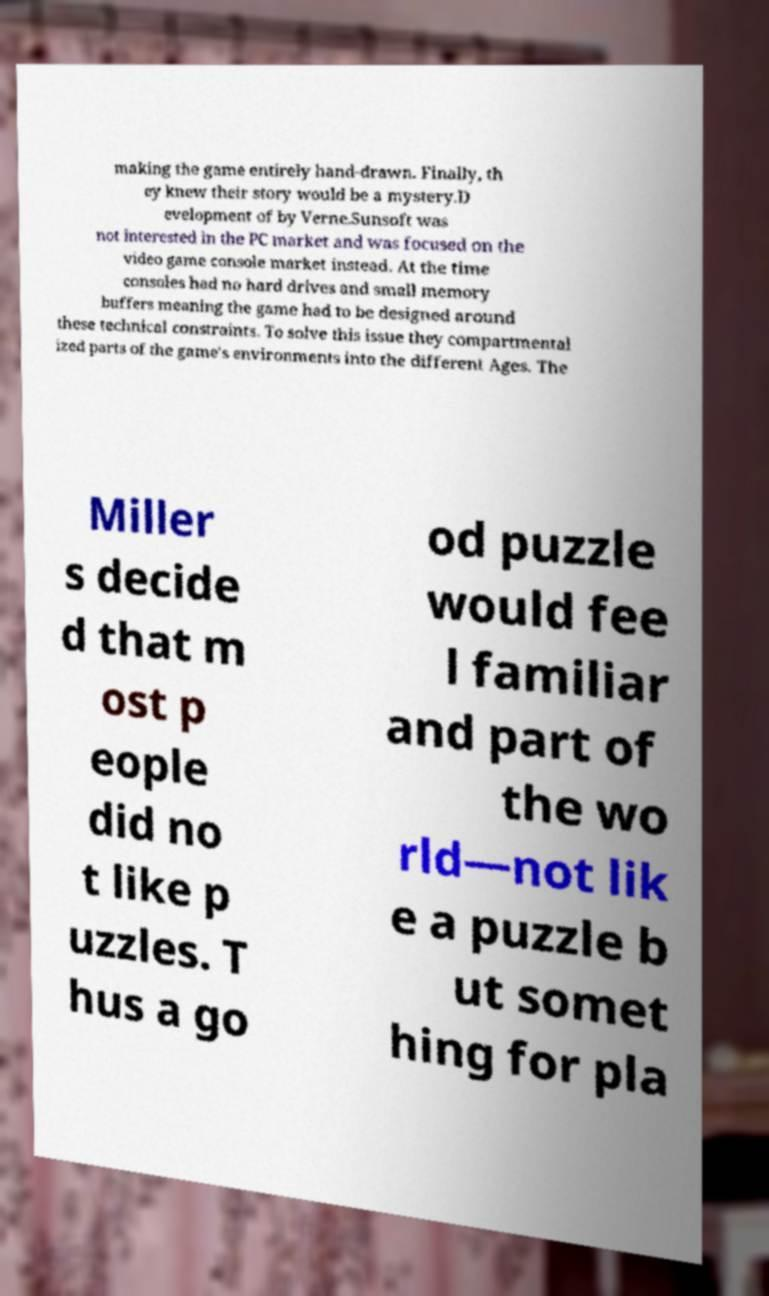Please identify and transcribe the text found in this image. making the game entirely hand-drawn. Finally, th ey knew their story would be a mystery.D evelopment of by Verne.Sunsoft was not interested in the PC market and was focused on the video game console market instead. At the time consoles had no hard drives and small memory buffers meaning the game had to be designed around these technical constraints. To solve this issue they compartmental ized parts of the game's environments into the different Ages. The Miller s decide d that m ost p eople did no t like p uzzles. T hus a go od puzzle would fee l familiar and part of the wo rld—not lik e a puzzle b ut somet hing for pla 